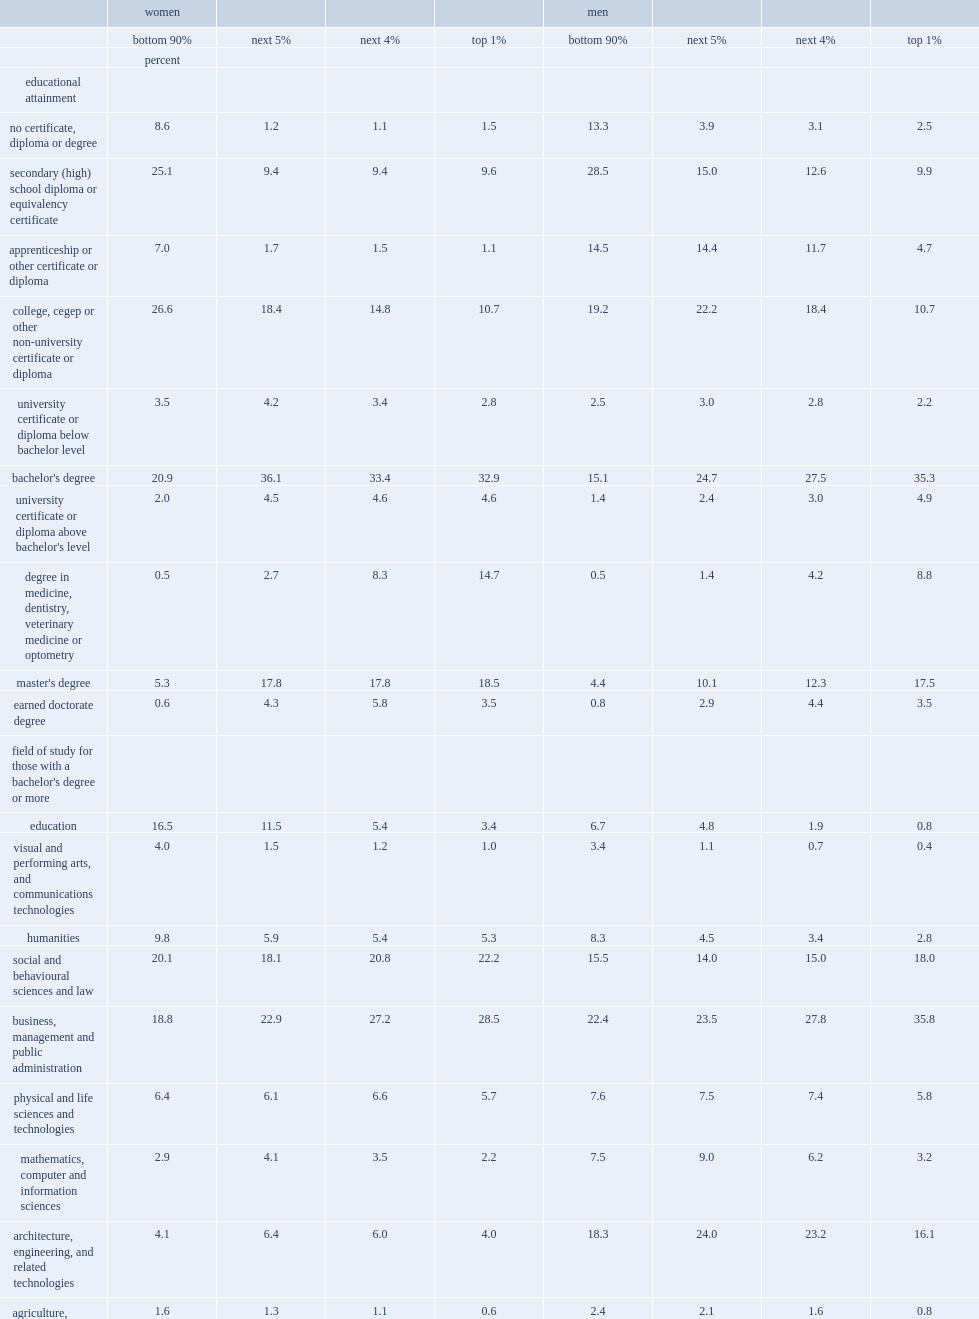What was the percentage of working women in the top 1% who obtained a bachelor's degree or higher in 2015. 74.2. What was the percentage of working men in the top 1% who obtained a bachelor's degree or higher in 2015. 70. For workers in the top 1%,who were more likely to obtain a university certificate or diploma above the bachelor's level,women or men? Women. For those in the top 1%,who were less likely to study in architecture, engineering, and related technologies,women or men? Women. What were the percentages of women in the top1% who studied in physical and life sciences and technology and their counterparts respectively? 5.7 5.8. What were the percentages of women in the top1% who studied in mathematics, computer science and information sciences and their counterparts respectively? 2.2 3.2. For workers in the top1%,who were more likely to have studied social and behavioural sciences and law,women or men? Women. What were the percentages of women in the top1% who studied inbusiness, management and public administration and their counterparts respectively? 28.5 35.8. 